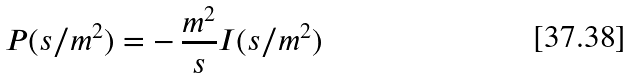Convert formula to latex. <formula><loc_0><loc_0><loc_500><loc_500>P ( s / m ^ { 2 } ) = - \, \frac { m ^ { 2 } } { s } I ( s / m ^ { 2 } )</formula> 